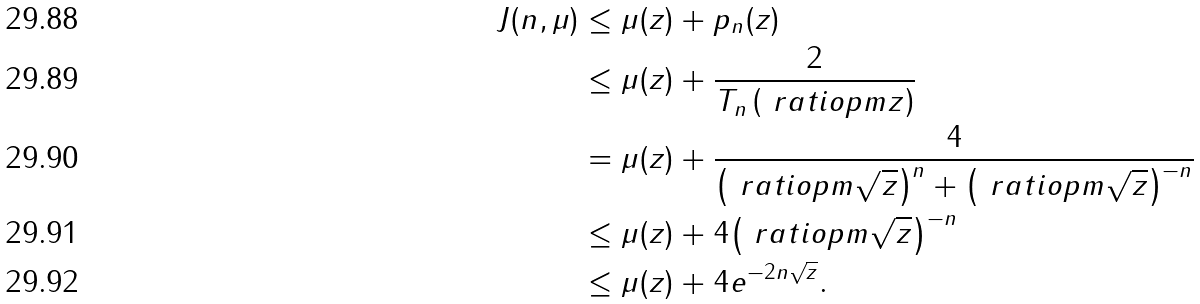Convert formula to latex. <formula><loc_0><loc_0><loc_500><loc_500>J ( n , \mu ) & \leq \mu ( z ) + p _ { n } ( z ) \\ & \leq \mu ( z ) + \frac { 2 } { T _ { n } \left ( \ r a t i o p m { z } \right ) } \\ & = \mu ( z ) + \frac { 4 } { { \left ( \ r a t i o p m { \sqrt { z } } \right ) } ^ { n } + { \left ( \ r a t i o p m { \sqrt { z } } \right ) } ^ { - n } } \\ & \leq \mu ( z ) + 4 { \left ( \ r a t i o p m { \sqrt { z } } \right ) } ^ { - n } \\ & \leq \mu ( z ) + 4 e ^ { - 2 n \sqrt { z } } .</formula> 